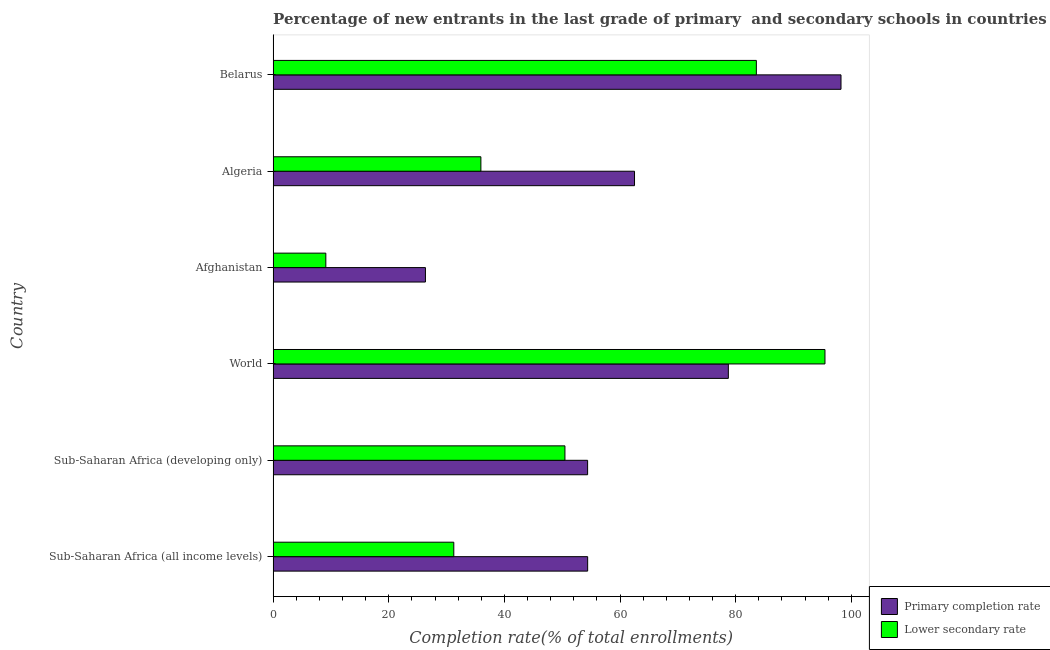How many different coloured bars are there?
Ensure brevity in your answer.  2. How many groups of bars are there?
Give a very brief answer. 6. Are the number of bars on each tick of the Y-axis equal?
Offer a terse response. Yes. How many bars are there on the 6th tick from the top?
Give a very brief answer. 2. What is the label of the 4th group of bars from the top?
Provide a succinct answer. World. In how many cases, is the number of bars for a given country not equal to the number of legend labels?
Offer a very short reply. 0. What is the completion rate in secondary schools in Belarus?
Make the answer very short. 83.58. Across all countries, what is the maximum completion rate in secondary schools?
Make the answer very short. 95.44. Across all countries, what is the minimum completion rate in primary schools?
Offer a very short reply. 26.34. In which country was the completion rate in secondary schools maximum?
Provide a short and direct response. World. In which country was the completion rate in secondary schools minimum?
Provide a succinct answer. Afghanistan. What is the total completion rate in secondary schools in the graph?
Keep it short and to the point. 305.8. What is the difference between the completion rate in primary schools in Algeria and that in World?
Your answer should be very brief. -16.23. What is the difference between the completion rate in secondary schools in Sub-Saharan Africa (all income levels) and the completion rate in primary schools in Belarus?
Make the answer very short. -66.97. What is the average completion rate in secondary schools per country?
Provide a short and direct response. 50.97. What is the difference between the completion rate in primary schools and completion rate in secondary schools in Sub-Saharan Africa (all income levels)?
Your answer should be compact. 23.15. In how many countries, is the completion rate in primary schools greater than 32 %?
Your answer should be compact. 5. What is the ratio of the completion rate in secondary schools in Afghanistan to that in Algeria?
Ensure brevity in your answer.  0.25. Is the difference between the completion rate in secondary schools in Algeria and Sub-Saharan Africa (developing only) greater than the difference between the completion rate in primary schools in Algeria and Sub-Saharan Africa (developing only)?
Offer a terse response. No. What is the difference between the highest and the second highest completion rate in secondary schools?
Your response must be concise. 11.87. What is the difference between the highest and the lowest completion rate in secondary schools?
Keep it short and to the point. 86.33. Is the sum of the completion rate in secondary schools in Algeria and World greater than the maximum completion rate in primary schools across all countries?
Your response must be concise. Yes. What does the 2nd bar from the top in World represents?
Make the answer very short. Primary completion rate. What does the 2nd bar from the bottom in World represents?
Keep it short and to the point. Lower secondary rate. How many bars are there?
Offer a terse response. 12. Are all the bars in the graph horizontal?
Offer a very short reply. Yes. How many countries are there in the graph?
Provide a succinct answer. 6. Are the values on the major ticks of X-axis written in scientific E-notation?
Keep it short and to the point. No. Does the graph contain any zero values?
Provide a succinct answer. No. Does the graph contain grids?
Your answer should be compact. No. How are the legend labels stacked?
Give a very brief answer. Vertical. What is the title of the graph?
Your answer should be very brief. Percentage of new entrants in the last grade of primary  and secondary schools in countries. What is the label or title of the X-axis?
Offer a terse response. Completion rate(% of total enrollments). What is the label or title of the Y-axis?
Give a very brief answer. Country. What is the Completion rate(% of total enrollments) of Primary completion rate in Sub-Saharan Africa (all income levels)?
Make the answer very short. 54.4. What is the Completion rate(% of total enrollments) of Lower secondary rate in Sub-Saharan Africa (all income levels)?
Offer a very short reply. 31.25. What is the Completion rate(% of total enrollments) in Primary completion rate in Sub-Saharan Africa (developing only)?
Give a very brief answer. 54.39. What is the Completion rate(% of total enrollments) in Lower secondary rate in Sub-Saharan Africa (developing only)?
Provide a succinct answer. 50.47. What is the Completion rate(% of total enrollments) of Primary completion rate in World?
Ensure brevity in your answer.  78.73. What is the Completion rate(% of total enrollments) of Lower secondary rate in World?
Give a very brief answer. 95.44. What is the Completion rate(% of total enrollments) of Primary completion rate in Afghanistan?
Your response must be concise. 26.34. What is the Completion rate(% of total enrollments) in Lower secondary rate in Afghanistan?
Offer a very short reply. 9.12. What is the Completion rate(% of total enrollments) in Primary completion rate in Algeria?
Provide a short and direct response. 62.5. What is the Completion rate(% of total enrollments) of Lower secondary rate in Algeria?
Your answer should be compact. 35.94. What is the Completion rate(% of total enrollments) in Primary completion rate in Belarus?
Offer a very short reply. 98.22. What is the Completion rate(% of total enrollments) of Lower secondary rate in Belarus?
Provide a short and direct response. 83.58. Across all countries, what is the maximum Completion rate(% of total enrollments) in Primary completion rate?
Keep it short and to the point. 98.22. Across all countries, what is the maximum Completion rate(% of total enrollments) of Lower secondary rate?
Your answer should be very brief. 95.44. Across all countries, what is the minimum Completion rate(% of total enrollments) of Primary completion rate?
Your answer should be compact. 26.34. Across all countries, what is the minimum Completion rate(% of total enrollments) in Lower secondary rate?
Keep it short and to the point. 9.12. What is the total Completion rate(% of total enrollments) of Primary completion rate in the graph?
Offer a very short reply. 374.59. What is the total Completion rate(% of total enrollments) of Lower secondary rate in the graph?
Your response must be concise. 305.8. What is the difference between the Completion rate(% of total enrollments) of Primary completion rate in Sub-Saharan Africa (all income levels) and that in Sub-Saharan Africa (developing only)?
Keep it short and to the point. 0.01. What is the difference between the Completion rate(% of total enrollments) in Lower secondary rate in Sub-Saharan Africa (all income levels) and that in Sub-Saharan Africa (developing only)?
Keep it short and to the point. -19.22. What is the difference between the Completion rate(% of total enrollments) of Primary completion rate in Sub-Saharan Africa (all income levels) and that in World?
Offer a very short reply. -24.33. What is the difference between the Completion rate(% of total enrollments) in Lower secondary rate in Sub-Saharan Africa (all income levels) and that in World?
Keep it short and to the point. -64.19. What is the difference between the Completion rate(% of total enrollments) of Primary completion rate in Sub-Saharan Africa (all income levels) and that in Afghanistan?
Make the answer very short. 28.06. What is the difference between the Completion rate(% of total enrollments) of Lower secondary rate in Sub-Saharan Africa (all income levels) and that in Afghanistan?
Your answer should be very brief. 22.13. What is the difference between the Completion rate(% of total enrollments) of Primary completion rate in Sub-Saharan Africa (all income levels) and that in Algeria?
Ensure brevity in your answer.  -8.11. What is the difference between the Completion rate(% of total enrollments) of Lower secondary rate in Sub-Saharan Africa (all income levels) and that in Algeria?
Provide a short and direct response. -4.69. What is the difference between the Completion rate(% of total enrollments) in Primary completion rate in Sub-Saharan Africa (all income levels) and that in Belarus?
Give a very brief answer. -43.82. What is the difference between the Completion rate(% of total enrollments) in Lower secondary rate in Sub-Saharan Africa (all income levels) and that in Belarus?
Keep it short and to the point. -52.33. What is the difference between the Completion rate(% of total enrollments) in Primary completion rate in Sub-Saharan Africa (developing only) and that in World?
Offer a terse response. -24.34. What is the difference between the Completion rate(% of total enrollments) in Lower secondary rate in Sub-Saharan Africa (developing only) and that in World?
Make the answer very short. -44.97. What is the difference between the Completion rate(% of total enrollments) of Primary completion rate in Sub-Saharan Africa (developing only) and that in Afghanistan?
Make the answer very short. 28.05. What is the difference between the Completion rate(% of total enrollments) in Lower secondary rate in Sub-Saharan Africa (developing only) and that in Afghanistan?
Provide a short and direct response. 41.36. What is the difference between the Completion rate(% of total enrollments) of Primary completion rate in Sub-Saharan Africa (developing only) and that in Algeria?
Your answer should be compact. -8.11. What is the difference between the Completion rate(% of total enrollments) of Lower secondary rate in Sub-Saharan Africa (developing only) and that in Algeria?
Your answer should be very brief. 14.54. What is the difference between the Completion rate(% of total enrollments) of Primary completion rate in Sub-Saharan Africa (developing only) and that in Belarus?
Ensure brevity in your answer.  -43.83. What is the difference between the Completion rate(% of total enrollments) in Lower secondary rate in Sub-Saharan Africa (developing only) and that in Belarus?
Offer a terse response. -33.11. What is the difference between the Completion rate(% of total enrollments) of Primary completion rate in World and that in Afghanistan?
Ensure brevity in your answer.  52.39. What is the difference between the Completion rate(% of total enrollments) in Lower secondary rate in World and that in Afghanistan?
Provide a short and direct response. 86.33. What is the difference between the Completion rate(% of total enrollments) in Primary completion rate in World and that in Algeria?
Offer a very short reply. 16.23. What is the difference between the Completion rate(% of total enrollments) in Lower secondary rate in World and that in Algeria?
Your answer should be very brief. 59.51. What is the difference between the Completion rate(% of total enrollments) of Primary completion rate in World and that in Belarus?
Keep it short and to the point. -19.49. What is the difference between the Completion rate(% of total enrollments) of Lower secondary rate in World and that in Belarus?
Make the answer very short. 11.87. What is the difference between the Completion rate(% of total enrollments) in Primary completion rate in Afghanistan and that in Algeria?
Provide a succinct answer. -36.16. What is the difference between the Completion rate(% of total enrollments) of Lower secondary rate in Afghanistan and that in Algeria?
Your response must be concise. -26.82. What is the difference between the Completion rate(% of total enrollments) of Primary completion rate in Afghanistan and that in Belarus?
Give a very brief answer. -71.88. What is the difference between the Completion rate(% of total enrollments) in Lower secondary rate in Afghanistan and that in Belarus?
Your answer should be compact. -74.46. What is the difference between the Completion rate(% of total enrollments) of Primary completion rate in Algeria and that in Belarus?
Keep it short and to the point. -35.71. What is the difference between the Completion rate(% of total enrollments) of Lower secondary rate in Algeria and that in Belarus?
Offer a terse response. -47.64. What is the difference between the Completion rate(% of total enrollments) of Primary completion rate in Sub-Saharan Africa (all income levels) and the Completion rate(% of total enrollments) of Lower secondary rate in Sub-Saharan Africa (developing only)?
Ensure brevity in your answer.  3.93. What is the difference between the Completion rate(% of total enrollments) of Primary completion rate in Sub-Saharan Africa (all income levels) and the Completion rate(% of total enrollments) of Lower secondary rate in World?
Ensure brevity in your answer.  -41.04. What is the difference between the Completion rate(% of total enrollments) in Primary completion rate in Sub-Saharan Africa (all income levels) and the Completion rate(% of total enrollments) in Lower secondary rate in Afghanistan?
Ensure brevity in your answer.  45.28. What is the difference between the Completion rate(% of total enrollments) of Primary completion rate in Sub-Saharan Africa (all income levels) and the Completion rate(% of total enrollments) of Lower secondary rate in Algeria?
Give a very brief answer. 18.46. What is the difference between the Completion rate(% of total enrollments) of Primary completion rate in Sub-Saharan Africa (all income levels) and the Completion rate(% of total enrollments) of Lower secondary rate in Belarus?
Your answer should be compact. -29.18. What is the difference between the Completion rate(% of total enrollments) of Primary completion rate in Sub-Saharan Africa (developing only) and the Completion rate(% of total enrollments) of Lower secondary rate in World?
Keep it short and to the point. -41.05. What is the difference between the Completion rate(% of total enrollments) of Primary completion rate in Sub-Saharan Africa (developing only) and the Completion rate(% of total enrollments) of Lower secondary rate in Afghanistan?
Your response must be concise. 45.28. What is the difference between the Completion rate(% of total enrollments) in Primary completion rate in Sub-Saharan Africa (developing only) and the Completion rate(% of total enrollments) in Lower secondary rate in Algeria?
Give a very brief answer. 18.46. What is the difference between the Completion rate(% of total enrollments) of Primary completion rate in Sub-Saharan Africa (developing only) and the Completion rate(% of total enrollments) of Lower secondary rate in Belarus?
Your answer should be very brief. -29.19. What is the difference between the Completion rate(% of total enrollments) of Primary completion rate in World and the Completion rate(% of total enrollments) of Lower secondary rate in Afghanistan?
Ensure brevity in your answer.  69.62. What is the difference between the Completion rate(% of total enrollments) in Primary completion rate in World and the Completion rate(% of total enrollments) in Lower secondary rate in Algeria?
Your answer should be very brief. 42.8. What is the difference between the Completion rate(% of total enrollments) of Primary completion rate in World and the Completion rate(% of total enrollments) of Lower secondary rate in Belarus?
Give a very brief answer. -4.85. What is the difference between the Completion rate(% of total enrollments) in Primary completion rate in Afghanistan and the Completion rate(% of total enrollments) in Lower secondary rate in Algeria?
Offer a very short reply. -9.59. What is the difference between the Completion rate(% of total enrollments) in Primary completion rate in Afghanistan and the Completion rate(% of total enrollments) in Lower secondary rate in Belarus?
Your answer should be compact. -57.24. What is the difference between the Completion rate(% of total enrollments) in Primary completion rate in Algeria and the Completion rate(% of total enrollments) in Lower secondary rate in Belarus?
Offer a terse response. -21.07. What is the average Completion rate(% of total enrollments) of Primary completion rate per country?
Provide a short and direct response. 62.43. What is the average Completion rate(% of total enrollments) of Lower secondary rate per country?
Provide a short and direct response. 50.97. What is the difference between the Completion rate(% of total enrollments) of Primary completion rate and Completion rate(% of total enrollments) of Lower secondary rate in Sub-Saharan Africa (all income levels)?
Offer a very short reply. 23.15. What is the difference between the Completion rate(% of total enrollments) in Primary completion rate and Completion rate(% of total enrollments) in Lower secondary rate in Sub-Saharan Africa (developing only)?
Offer a very short reply. 3.92. What is the difference between the Completion rate(% of total enrollments) in Primary completion rate and Completion rate(% of total enrollments) in Lower secondary rate in World?
Give a very brief answer. -16.71. What is the difference between the Completion rate(% of total enrollments) of Primary completion rate and Completion rate(% of total enrollments) of Lower secondary rate in Afghanistan?
Ensure brevity in your answer.  17.23. What is the difference between the Completion rate(% of total enrollments) in Primary completion rate and Completion rate(% of total enrollments) in Lower secondary rate in Algeria?
Provide a short and direct response. 26.57. What is the difference between the Completion rate(% of total enrollments) of Primary completion rate and Completion rate(% of total enrollments) of Lower secondary rate in Belarus?
Your answer should be very brief. 14.64. What is the ratio of the Completion rate(% of total enrollments) of Lower secondary rate in Sub-Saharan Africa (all income levels) to that in Sub-Saharan Africa (developing only)?
Provide a short and direct response. 0.62. What is the ratio of the Completion rate(% of total enrollments) of Primary completion rate in Sub-Saharan Africa (all income levels) to that in World?
Your answer should be compact. 0.69. What is the ratio of the Completion rate(% of total enrollments) of Lower secondary rate in Sub-Saharan Africa (all income levels) to that in World?
Keep it short and to the point. 0.33. What is the ratio of the Completion rate(% of total enrollments) in Primary completion rate in Sub-Saharan Africa (all income levels) to that in Afghanistan?
Make the answer very short. 2.07. What is the ratio of the Completion rate(% of total enrollments) in Lower secondary rate in Sub-Saharan Africa (all income levels) to that in Afghanistan?
Your response must be concise. 3.43. What is the ratio of the Completion rate(% of total enrollments) in Primary completion rate in Sub-Saharan Africa (all income levels) to that in Algeria?
Give a very brief answer. 0.87. What is the ratio of the Completion rate(% of total enrollments) in Lower secondary rate in Sub-Saharan Africa (all income levels) to that in Algeria?
Provide a succinct answer. 0.87. What is the ratio of the Completion rate(% of total enrollments) of Primary completion rate in Sub-Saharan Africa (all income levels) to that in Belarus?
Give a very brief answer. 0.55. What is the ratio of the Completion rate(% of total enrollments) of Lower secondary rate in Sub-Saharan Africa (all income levels) to that in Belarus?
Offer a very short reply. 0.37. What is the ratio of the Completion rate(% of total enrollments) in Primary completion rate in Sub-Saharan Africa (developing only) to that in World?
Give a very brief answer. 0.69. What is the ratio of the Completion rate(% of total enrollments) of Lower secondary rate in Sub-Saharan Africa (developing only) to that in World?
Ensure brevity in your answer.  0.53. What is the ratio of the Completion rate(% of total enrollments) of Primary completion rate in Sub-Saharan Africa (developing only) to that in Afghanistan?
Your answer should be very brief. 2.06. What is the ratio of the Completion rate(% of total enrollments) in Lower secondary rate in Sub-Saharan Africa (developing only) to that in Afghanistan?
Your answer should be compact. 5.54. What is the ratio of the Completion rate(% of total enrollments) in Primary completion rate in Sub-Saharan Africa (developing only) to that in Algeria?
Offer a terse response. 0.87. What is the ratio of the Completion rate(% of total enrollments) in Lower secondary rate in Sub-Saharan Africa (developing only) to that in Algeria?
Your answer should be compact. 1.4. What is the ratio of the Completion rate(% of total enrollments) of Primary completion rate in Sub-Saharan Africa (developing only) to that in Belarus?
Keep it short and to the point. 0.55. What is the ratio of the Completion rate(% of total enrollments) in Lower secondary rate in Sub-Saharan Africa (developing only) to that in Belarus?
Offer a terse response. 0.6. What is the ratio of the Completion rate(% of total enrollments) in Primary completion rate in World to that in Afghanistan?
Keep it short and to the point. 2.99. What is the ratio of the Completion rate(% of total enrollments) of Lower secondary rate in World to that in Afghanistan?
Make the answer very short. 10.47. What is the ratio of the Completion rate(% of total enrollments) of Primary completion rate in World to that in Algeria?
Your response must be concise. 1.26. What is the ratio of the Completion rate(% of total enrollments) of Lower secondary rate in World to that in Algeria?
Your response must be concise. 2.66. What is the ratio of the Completion rate(% of total enrollments) of Primary completion rate in World to that in Belarus?
Make the answer very short. 0.8. What is the ratio of the Completion rate(% of total enrollments) in Lower secondary rate in World to that in Belarus?
Your response must be concise. 1.14. What is the ratio of the Completion rate(% of total enrollments) in Primary completion rate in Afghanistan to that in Algeria?
Ensure brevity in your answer.  0.42. What is the ratio of the Completion rate(% of total enrollments) in Lower secondary rate in Afghanistan to that in Algeria?
Offer a terse response. 0.25. What is the ratio of the Completion rate(% of total enrollments) of Primary completion rate in Afghanistan to that in Belarus?
Offer a terse response. 0.27. What is the ratio of the Completion rate(% of total enrollments) of Lower secondary rate in Afghanistan to that in Belarus?
Offer a very short reply. 0.11. What is the ratio of the Completion rate(% of total enrollments) in Primary completion rate in Algeria to that in Belarus?
Make the answer very short. 0.64. What is the ratio of the Completion rate(% of total enrollments) of Lower secondary rate in Algeria to that in Belarus?
Ensure brevity in your answer.  0.43. What is the difference between the highest and the second highest Completion rate(% of total enrollments) in Primary completion rate?
Give a very brief answer. 19.49. What is the difference between the highest and the second highest Completion rate(% of total enrollments) of Lower secondary rate?
Your response must be concise. 11.87. What is the difference between the highest and the lowest Completion rate(% of total enrollments) of Primary completion rate?
Your answer should be compact. 71.88. What is the difference between the highest and the lowest Completion rate(% of total enrollments) in Lower secondary rate?
Offer a very short reply. 86.33. 